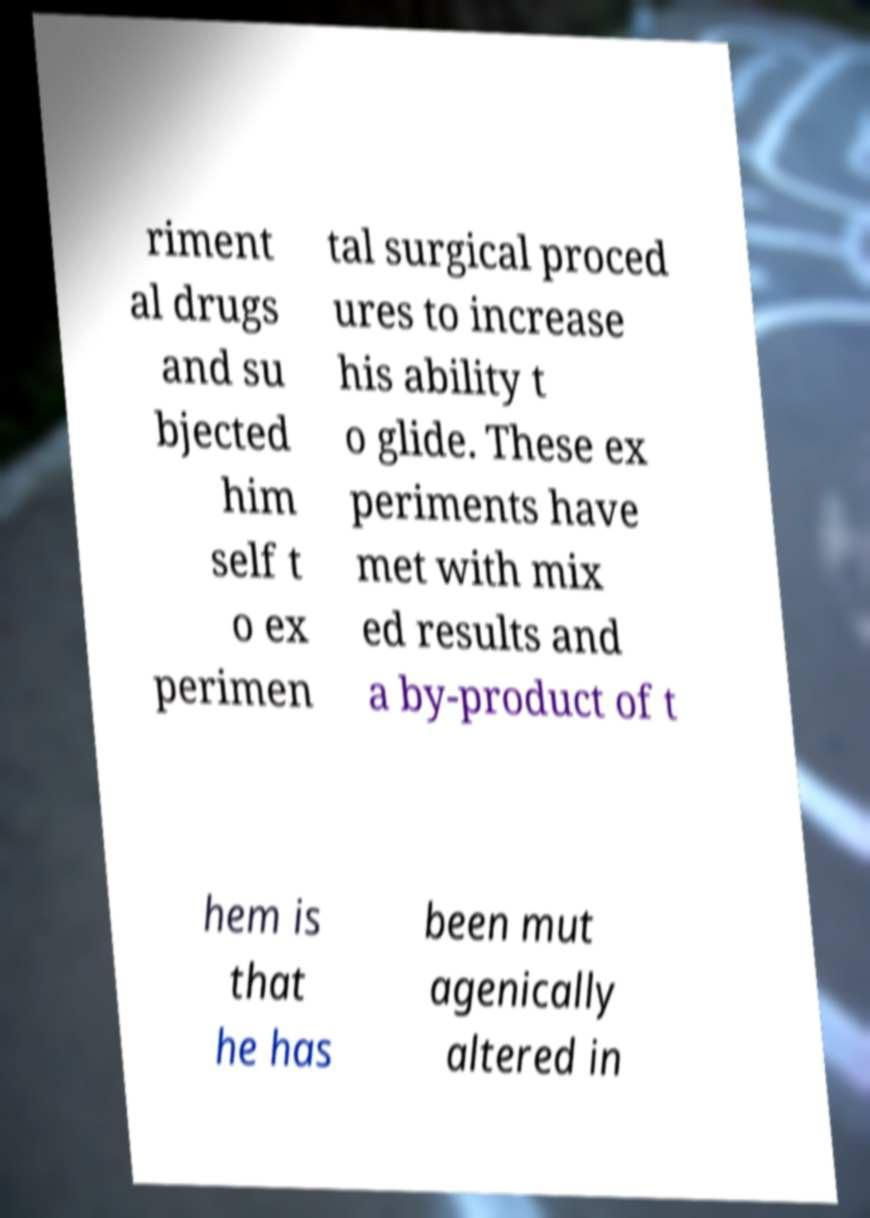Please identify and transcribe the text found in this image. riment al drugs and su bjected him self t o ex perimen tal surgical proced ures to increase his ability t o glide. These ex periments have met with mix ed results and a by-product of t hem is that he has been mut agenically altered in 